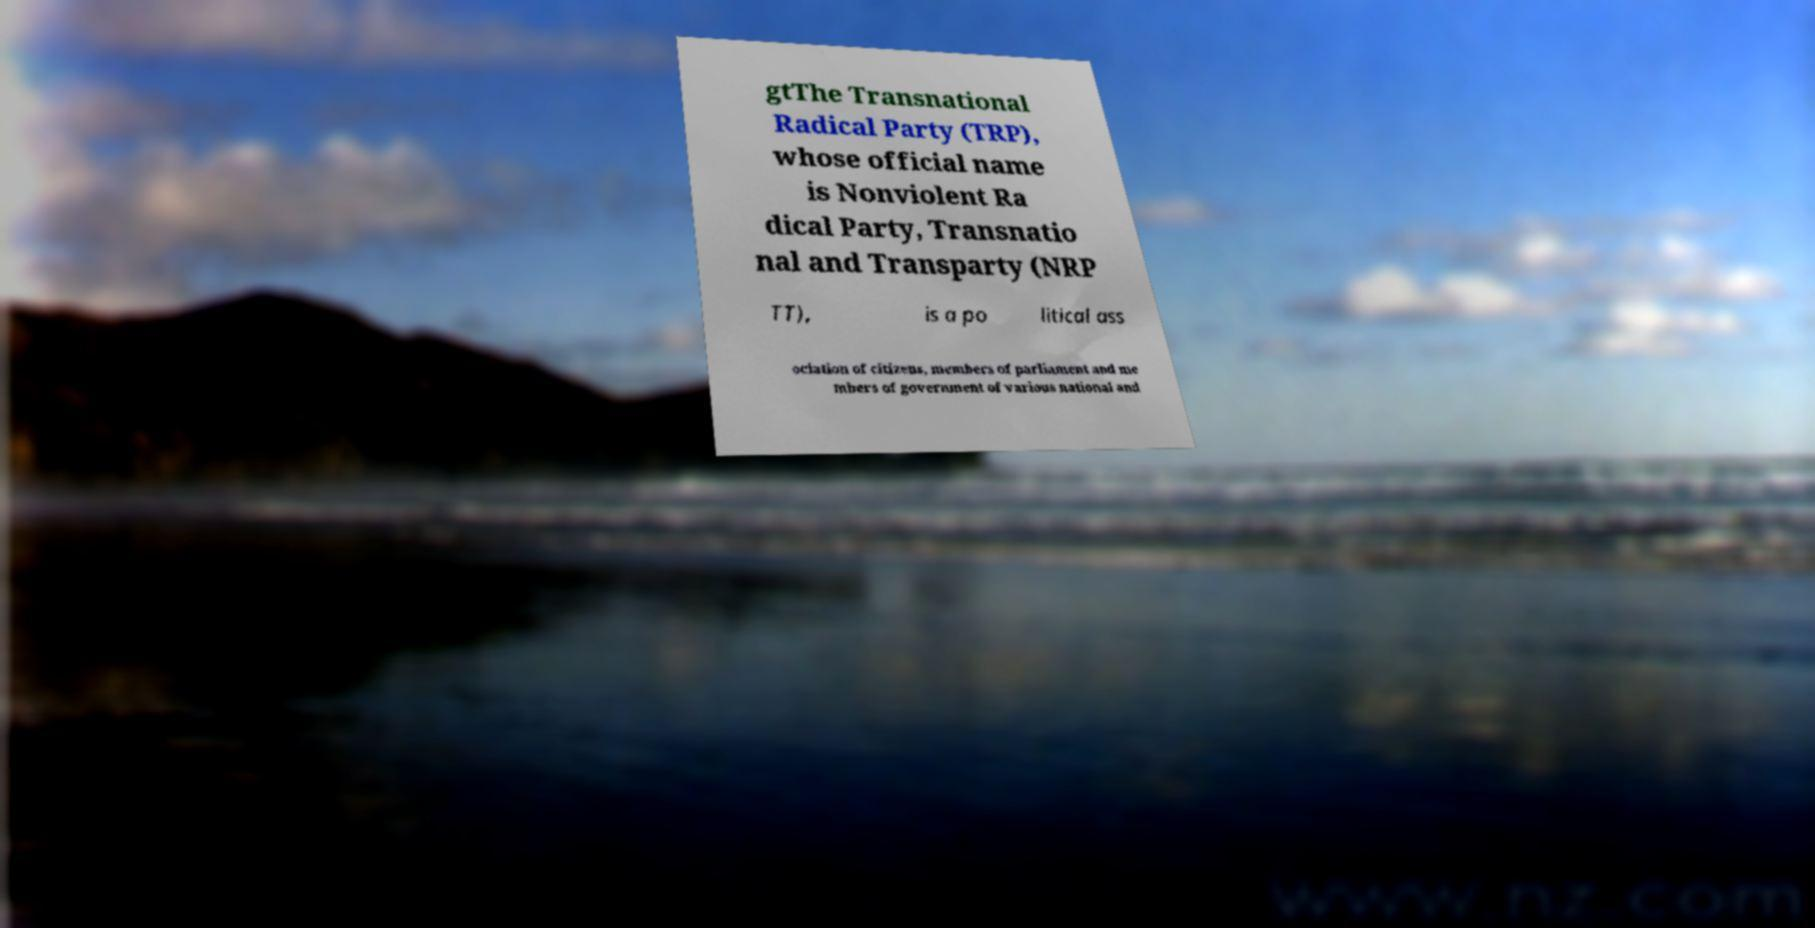Can you accurately transcribe the text from the provided image for me? gtThe Transnational Radical Party (TRP), whose official name is Nonviolent Ra dical Party, Transnatio nal and Transparty (NRP TT), is a po litical ass ociation of citizens, members of parliament and me mbers of government of various national and 